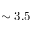<formula> <loc_0><loc_0><loc_500><loc_500>\sim 3 . 5</formula> 